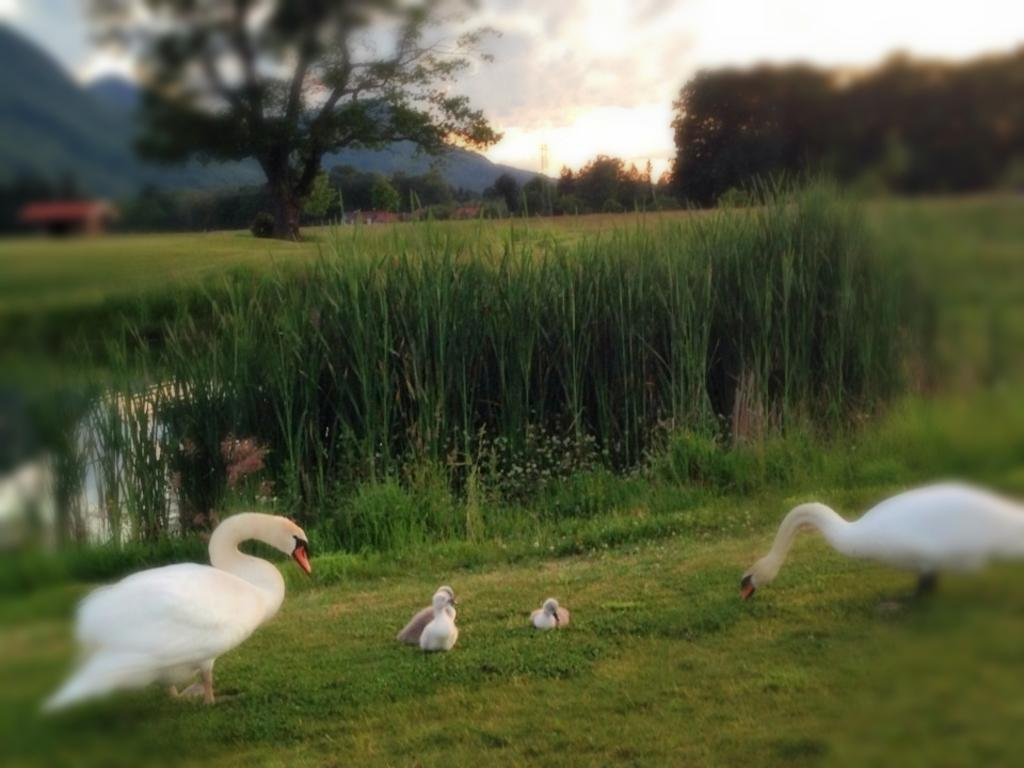What type of animals are present in the image? There are ducks and ducklings in the image. Where are the ducks and ducklings located? They are on the ground in the image. What can be seen in the background of the image? There are trees, a building, hills, and the sky visible in the image. What is the condition of the sky in the image? The sky is visible with clouds in the image. What is the price of the brush used to clean the meat in the image? There is no brush or meat present in the image, so it is not possible to determine the price of a brush used for cleaning meat. 